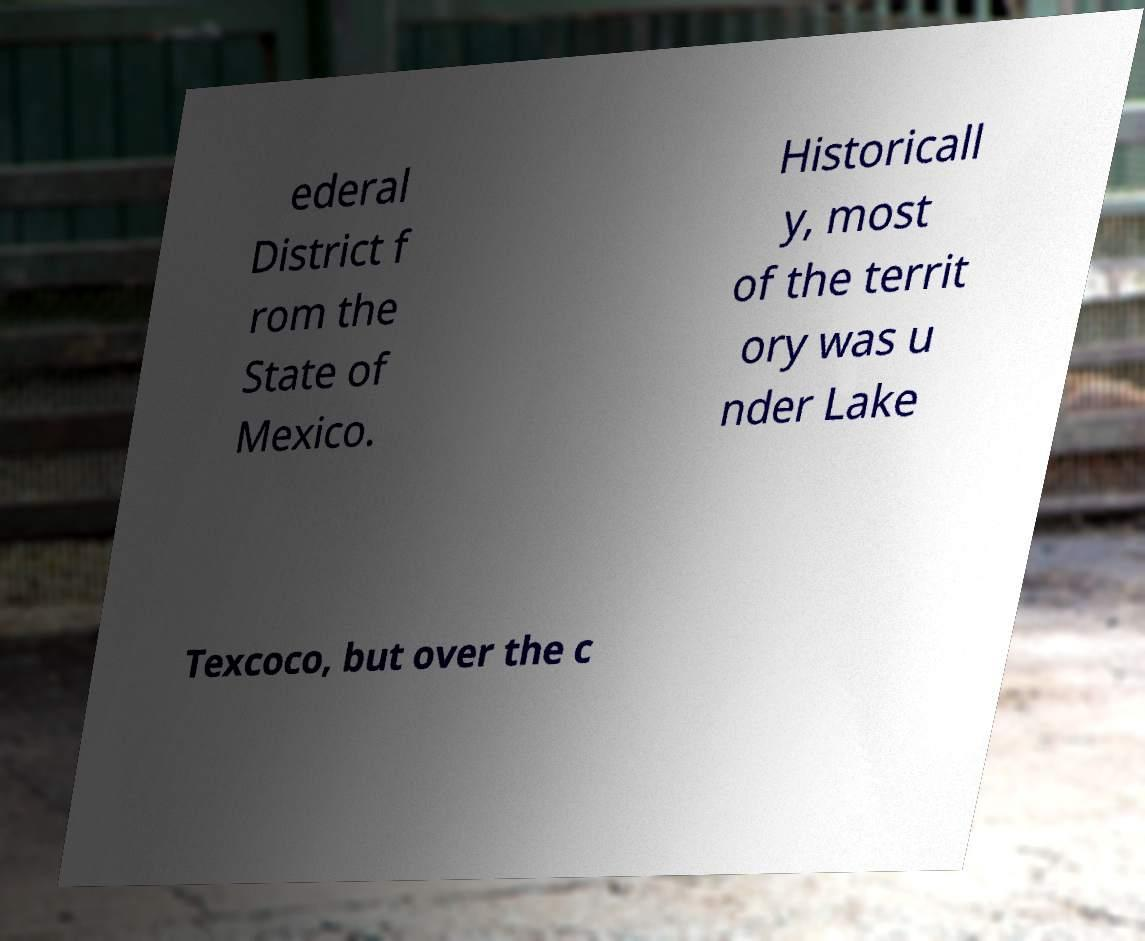Could you extract and type out the text from this image? ederal District f rom the State of Mexico. Historicall y, most of the territ ory was u nder Lake Texcoco, but over the c 